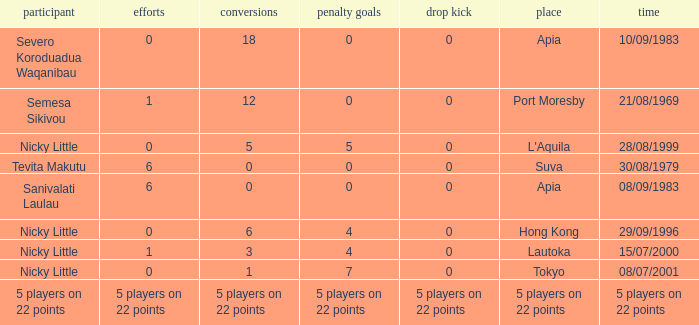How many drops did Nicky Little have in Hong Kong? 0.0. 